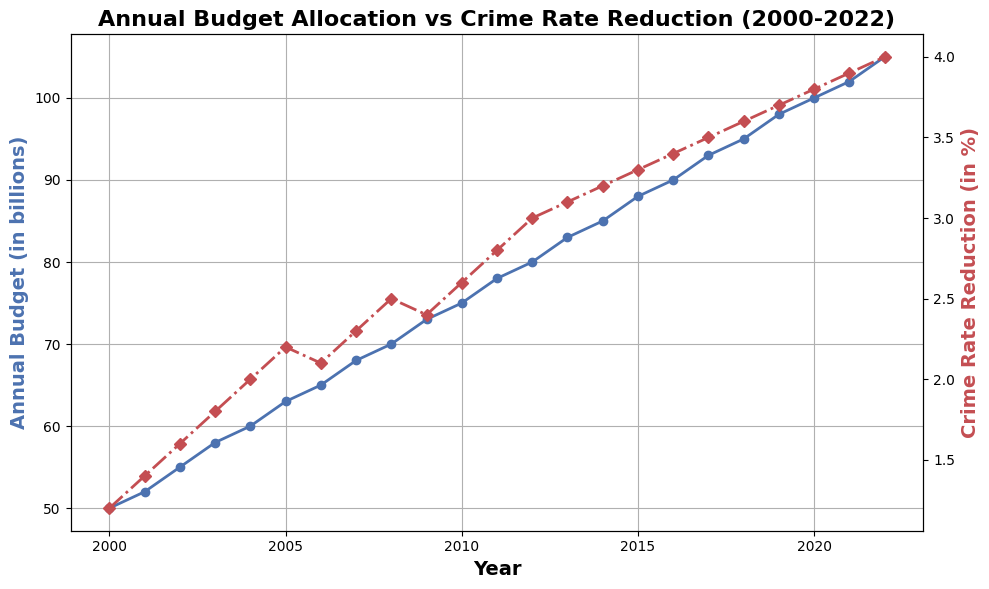What is the overall trend of the Annual Budget for Law Enforcement from 2000 to 2022? The line chart for the Annual Budget shows a consistent upward trend from 2000 to 2022. The budget starts at $50 billion in 2000 and increases steadily to $105 billion by 2022.
Answer: Increasing Which year shows the highest percentage of Crime Rate Reduction, and what is the percentage? The highest percentage of Crime Rate Reduction is observed in 2022, where the Crime Rate Reduction is 4.0%. This is visible by examining the red line in the graph, which peaks at 2022.
Answer: 2022, 4.0% Was there any year where the Annual Budget decreased? By looking at the blue line representing the Annual Budget, it displays a steady increase every year without any dips, indicating that the budget did not decrease in any year from 2000 to 2022.
Answer: No How many times did the Crime Rate Reduction percentage decrease compared to the previous year? The red line representing Crime Rate Reduction shows two instances of decrease. Between 2005 to 2006, it decreased from 2.2% to 2.1%, and between 2008 to 2009, it decreased from 2.5% to 2.4%.
Answer: 2 Between 2010 and 2015, what is the total increase in Annual Budget for Law Enforcement? In 2010, the Annual Budget is $75 billion and it increases to $88 billion by 2015. The total increase is found by subtracting these values: $88 billion - $75 billion = $13 billion.
Answer: $13 billion Compare the trend in Crime Rate Reduction between 2000 to 2010 and 2010 to 2022. Which period has a higher average percentage increase? From 2000 to 2010, the Crime Rate Reduction increased from 1.2% to 2.6%, a total increase of 1.4%. From 2010 to 2022, it increased from 2.6% to 4.0%, a total increase of 1.4%. The average annual increase for 2000-2010 is 0.14% per year (1.4%/10) and for 2010-2022 is 0.12% per year (1.4%/12). Hence, the 2000 to 2010 period had a higher average percentage increase.
Answer: 2000 to 2010 What visual element in the chart indicates the Annual Budget, and how is it visually distinct from the Crime Rate Reduction? The Annual Budget is represented by the blue line with circular markers, while the Crime Rate Reduction is represented by the red line with diamond markers. The colors and distinct marker types visually distinguish the two variables.
Answer: Blue line with circular markers In which year did the Annual Budget cross the 80 billion mark, and what was the corresponding Crime Rate Reduction for that year? The Annual Budget first crosses the 80 billion mark in 2012. The corresponding Crime Rate Reduction for that year is 3.0%, as shown by the red line.
Answer: 2012, 3.0% If you combine the trends of both the Annual Budget and Crime Rate Reduction, could any correlation be inferred between the two variables? By observing both the blue and red lines, it appears that as the Annual Budget increases, the Crime Rate Reduction generally also increases. This suggests a positive correlation where increased funding is associated with a greater reduction in crime rate.
Answer: Positive correlation 